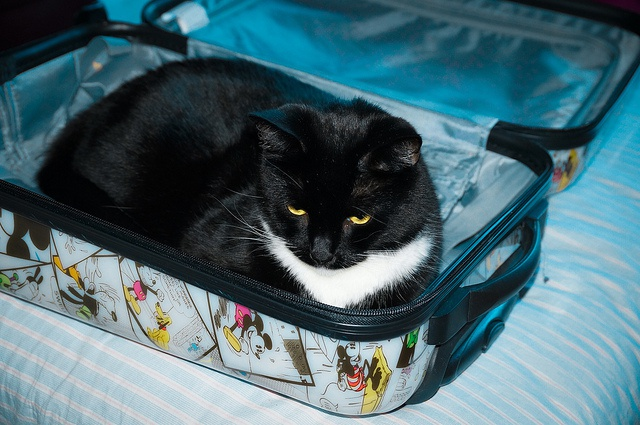Describe the objects in this image and their specific colors. I can see suitcase in black, teal, and darkgray tones, cat in black, white, gray, and blue tones, and bed in black and lightblue tones in this image. 